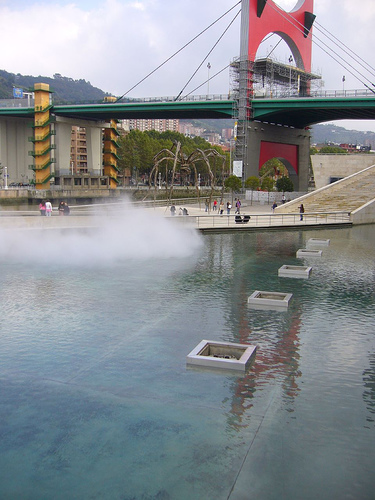<image>
Is the sky behind the bridge? Yes. From this viewpoint, the sky is positioned behind the bridge, with the bridge partially or fully occluding the sky. 